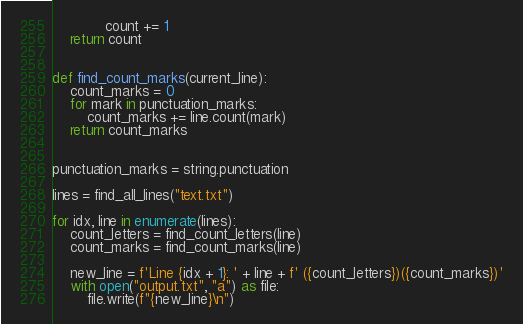<code> <loc_0><loc_0><loc_500><loc_500><_Python_>            count += 1
    return count


def find_count_marks(current_line):
    count_marks = 0
    for mark in punctuation_marks:
        count_marks += line.count(mark)
    return count_marks


punctuation_marks = string.punctuation

lines = find_all_lines("text.txt")

for idx, line in enumerate(lines):
    count_letters = find_count_letters(line)
    count_marks = find_count_marks(line)

    new_line = f'Line {idx + 1}: ' + line + f' ({count_letters})({count_marks})'
    with open("output.txt", "a") as file:
        file.write(f"{new_line}\n")






</code> 